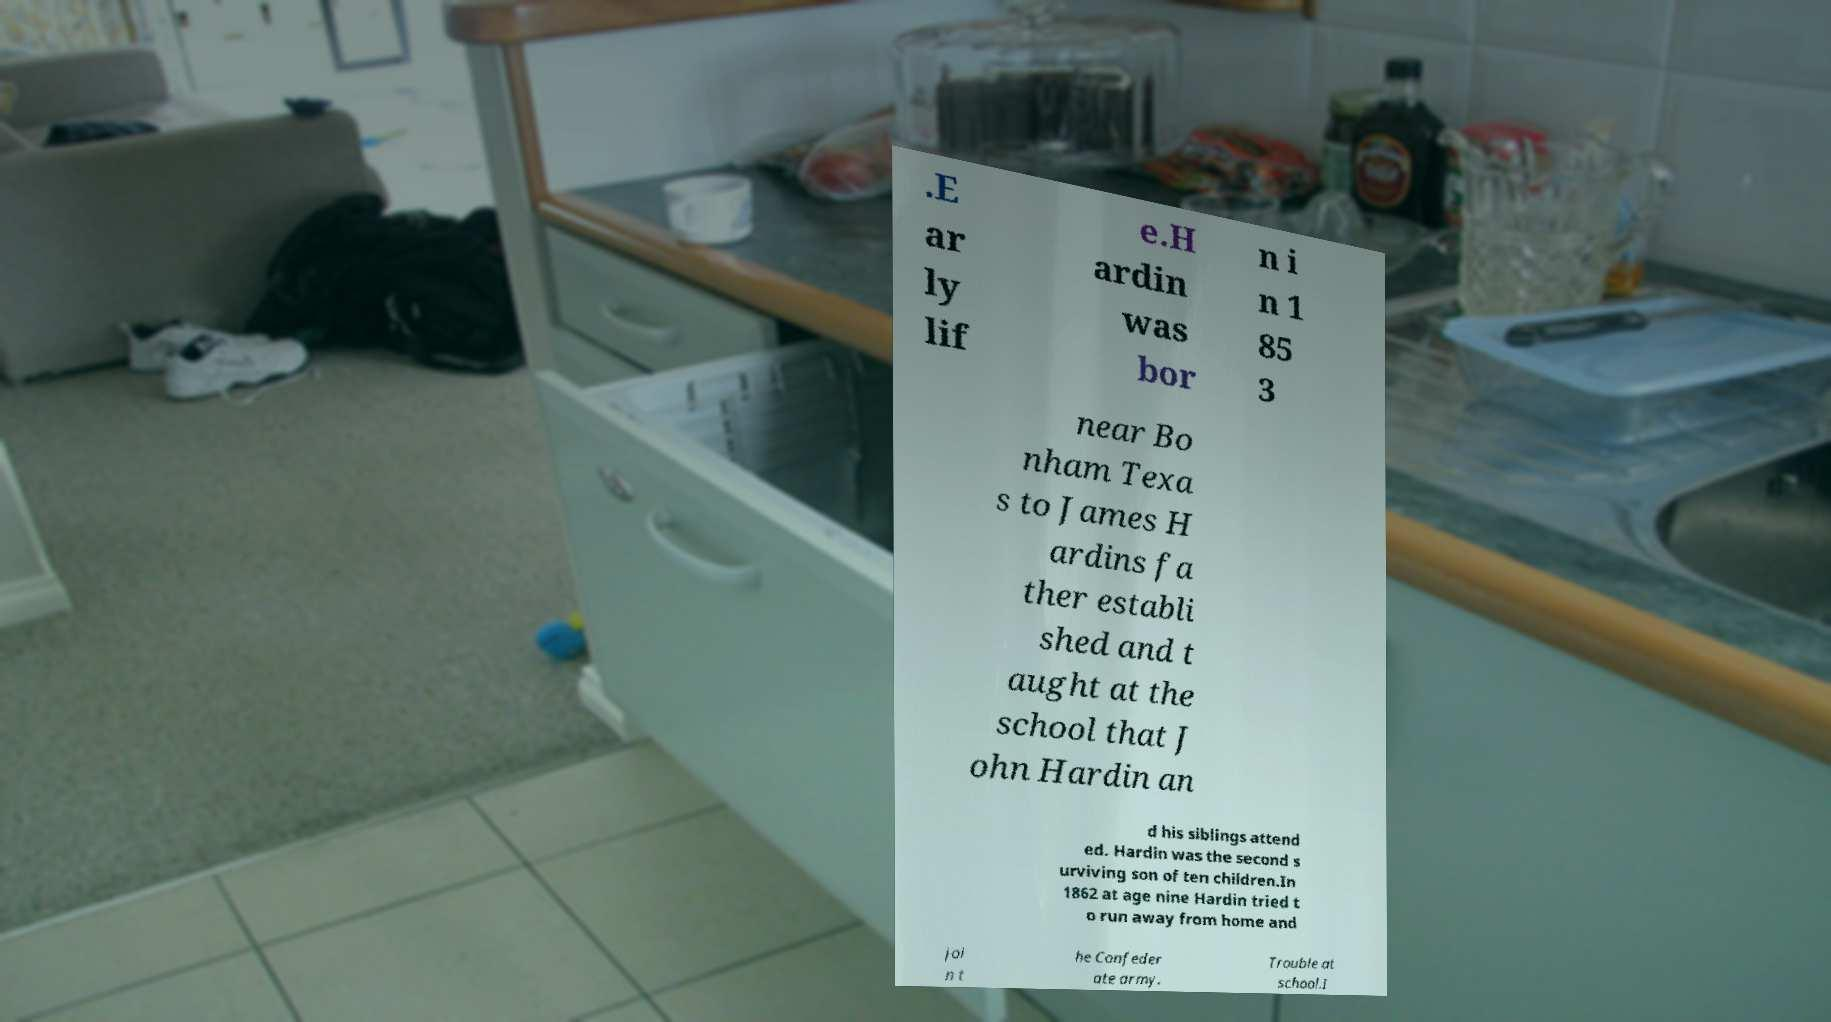Please identify and transcribe the text found in this image. .E ar ly lif e.H ardin was bor n i n 1 85 3 near Bo nham Texa s to James H ardins fa ther establi shed and t aught at the school that J ohn Hardin an d his siblings attend ed. Hardin was the second s urviving son of ten children.In 1862 at age nine Hardin tried t o run away from home and joi n t he Confeder ate army. Trouble at school.I 